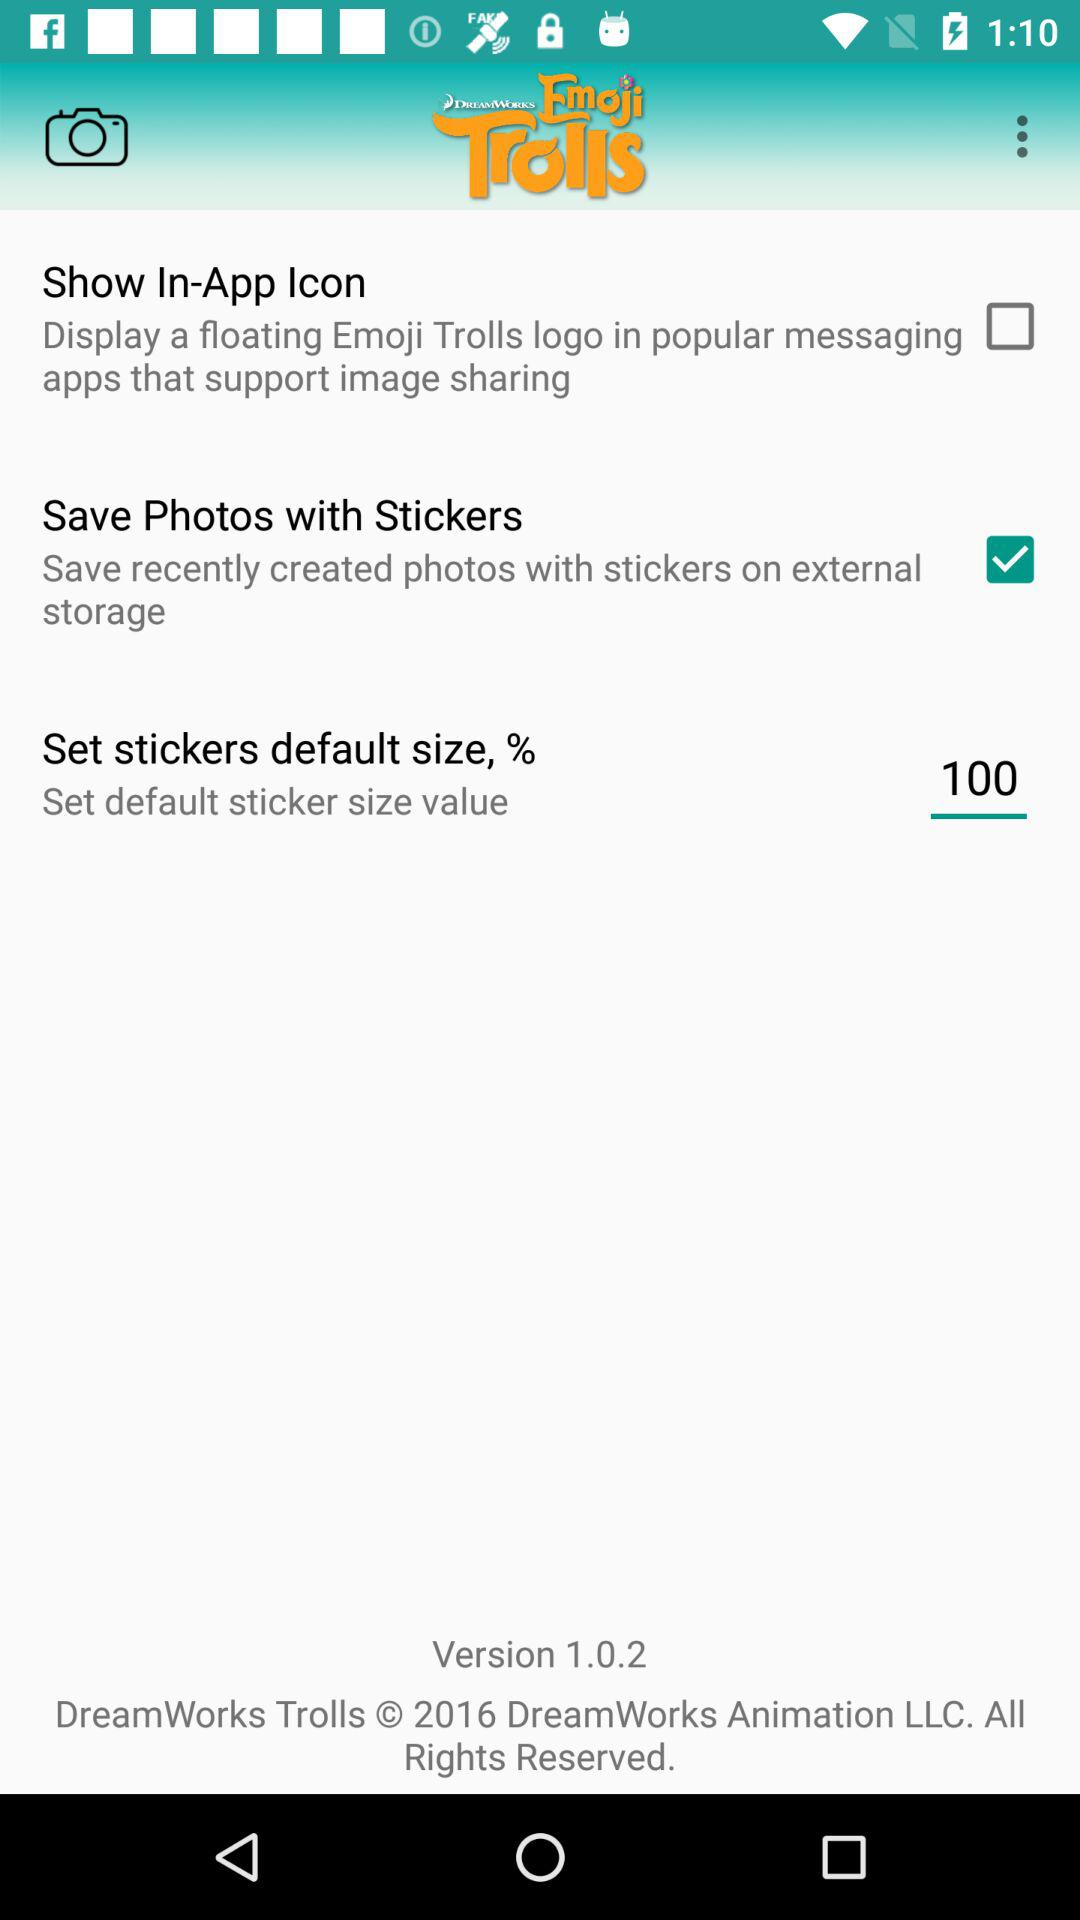What's the status of "Save Photos with Stickers"? The status is "on". 